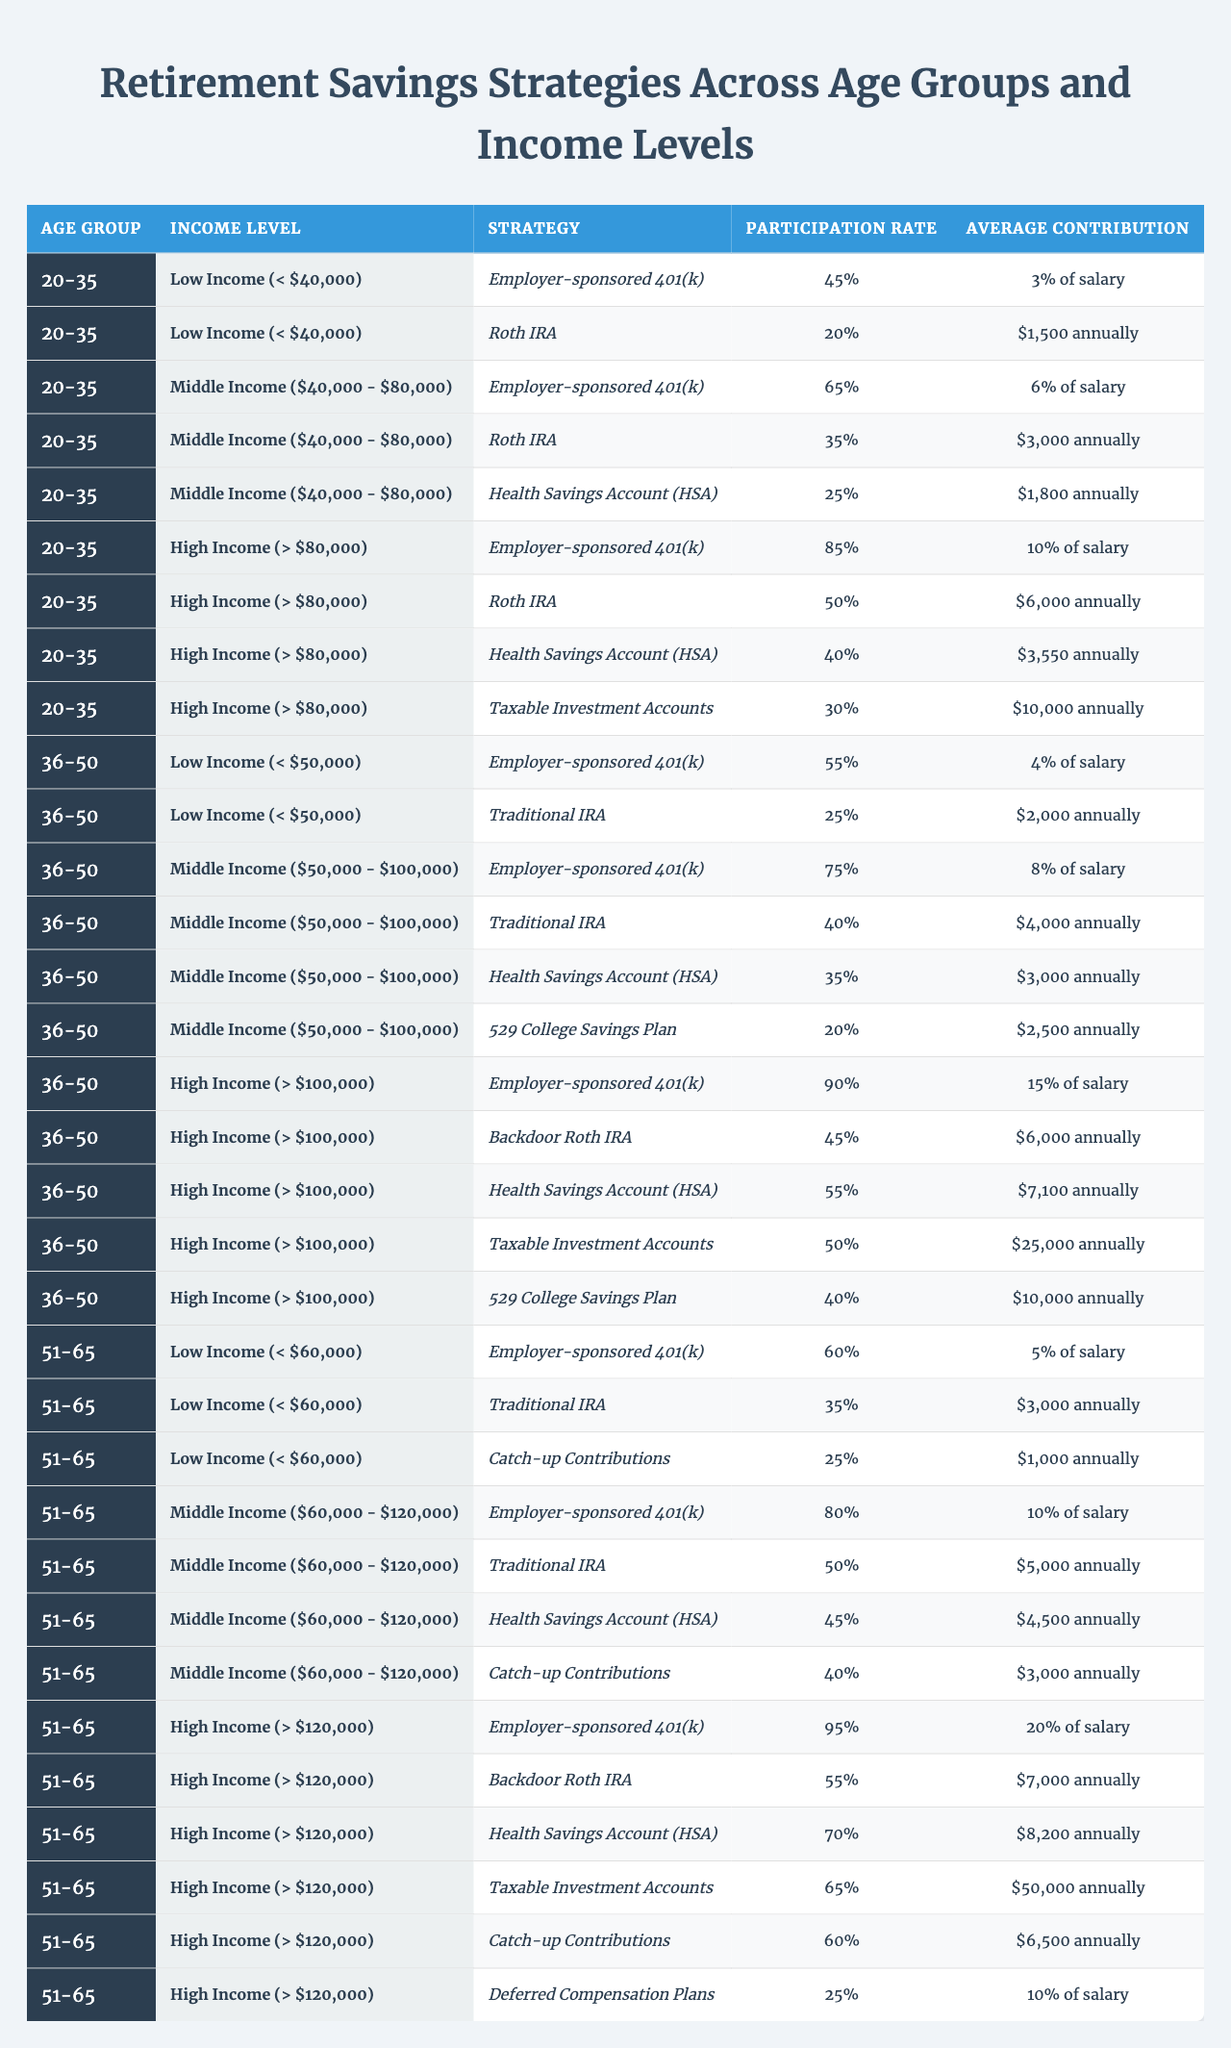What is the participation rate for "Employer-sponsored 401(k)" among individuals aged 20-35 with a high income? Looking at the table, for the age group of 20-35 and the income level "High Income (> $80,000)", the participation rate for "Employer-sponsored 401(k)" is 85%.
Answer: 85% Which age group has the highest average contribution for the "Health Savings Account (HSA)" among high-income earners? In the table, the age group of 51-65 has the highest average contribution for "Health Savings Account (HSA)" at $8,200, compared to 40% participation and average contributions of $3,550 in the 20-35 age group and $7,100 in the 36-50 age group.
Answer: 51-65 Is the participation rate for "Roth IRA" greater among low-income individuals aged 36-50 or those aged 20-35? Reviewing the table, low-income individuals aged 36-50 have a participation rate of 25% for "Roth IRA", while those aged 20-35 have a participation rate of 20%. Therefore, low-income individuals aged 36-50 have a greater participation rate.
Answer: Yes What is the difference in average contributions for "Taxable Investment Accounts" between the age groups 36-50 and 51-65? For age group 36-50, the average contribution for "Taxable Investment Accounts" is $25,000 among high-income earners, while for age group 51-65, it is $50,000 among high-income earners. The difference is calculated as $50,000 - $25,000 = $25,000.
Answer: $25,000 Which income group has the lowest participation rate for "Catch-up Contributions"? The table shows that among the age group of 51-65, the lowest participation rate for "Catch-up Contributions" is 25% in the high-income bracket, as compared to 40% in the middle income category and 25% in the low income category.
Answer: Low Income (< $60,000) What is the average participation rate for "Employer-sponsored 401(k)" across all age groups for individuals with middle income? Gathering data from the table, the participation rates for "Employer-sponsored 401(k)" in middle-income individuals are: 65% (20-35), 75% (36-50), and 80% (51-65). The average is (65 + 75 + 80) / 3 = 73.33%.
Answer: 73.33% How does the average contribution for "Traditional IRA" for low-income participants aged 51-65 compare to middle-income participants aged 36-50? For low-income participants aged 51-65, the average contribution for "Traditional IRA" is $3,000 annually, while for middle-income participants aged 36-50, it is $4,000 annually. Therefore, the contribution for low-income participants is $1,000 lower.
Answer: $1,000 Which strategy has the highest participation rate amongst high-income individuals aged 36-50? According to the data, the strategy with the highest participation rate among high-income individuals aged 36-50 is "Employer-sponsored 401(k)" at 90%.
Answer: Employer-sponsored 401(k) What is the median average contribution for "Health Savings Account (HSA)" across all age groups and income levels? To find the median average contribution for "Health Savings Account (HSA)", we identify the contributions: $1,800, $3,000, $4,500, $7,100, and $8,200 (for low, middle, and high income in each age group). Ranking these amounts gives $1,800, $3,000, $4,500, $7,100, and $8,200. The median is the middle value, which is $4,500.
Answer: $4,500 What proportion of individuals aged 36-50 with middle income contribute to a 529 College Savings Plan? The table states that in the middle income category for individuals aged 36-50, 20% contribute to a 529 College Savings Plan. Thus, the proportion is 20%.
Answer: 20% Which age group sees the greatest use of "Backdoor Roth IRA" in the high-income category? From the table, the age group of 51-65 shows a participation rate for "Backdoor Roth IRA" at 55%, which is higher than the 45% in the 36-50 age group, indicating that 51-65 has the greatest use in the high-income category.
Answer: 51-65 